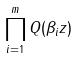Convert formula to latex. <formula><loc_0><loc_0><loc_500><loc_500>\prod _ { i = 1 } ^ { m } Q ( \beta _ { i } z )</formula> 